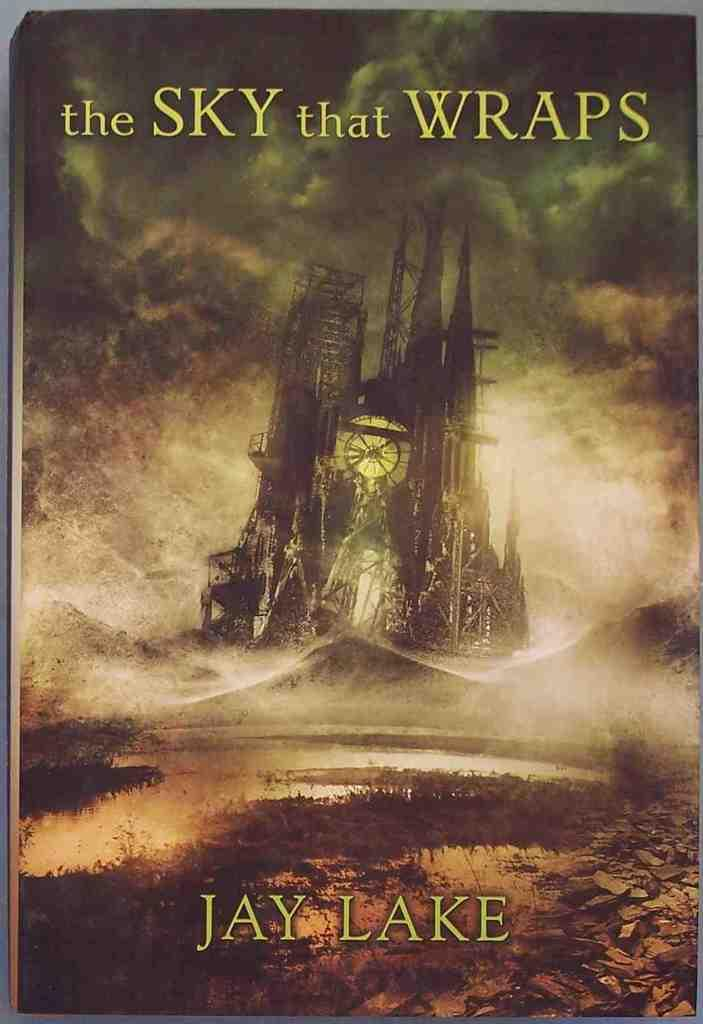<image>
Present a compact description of the photo's key features. A book cover that is titled "the Sky that Wraps". 